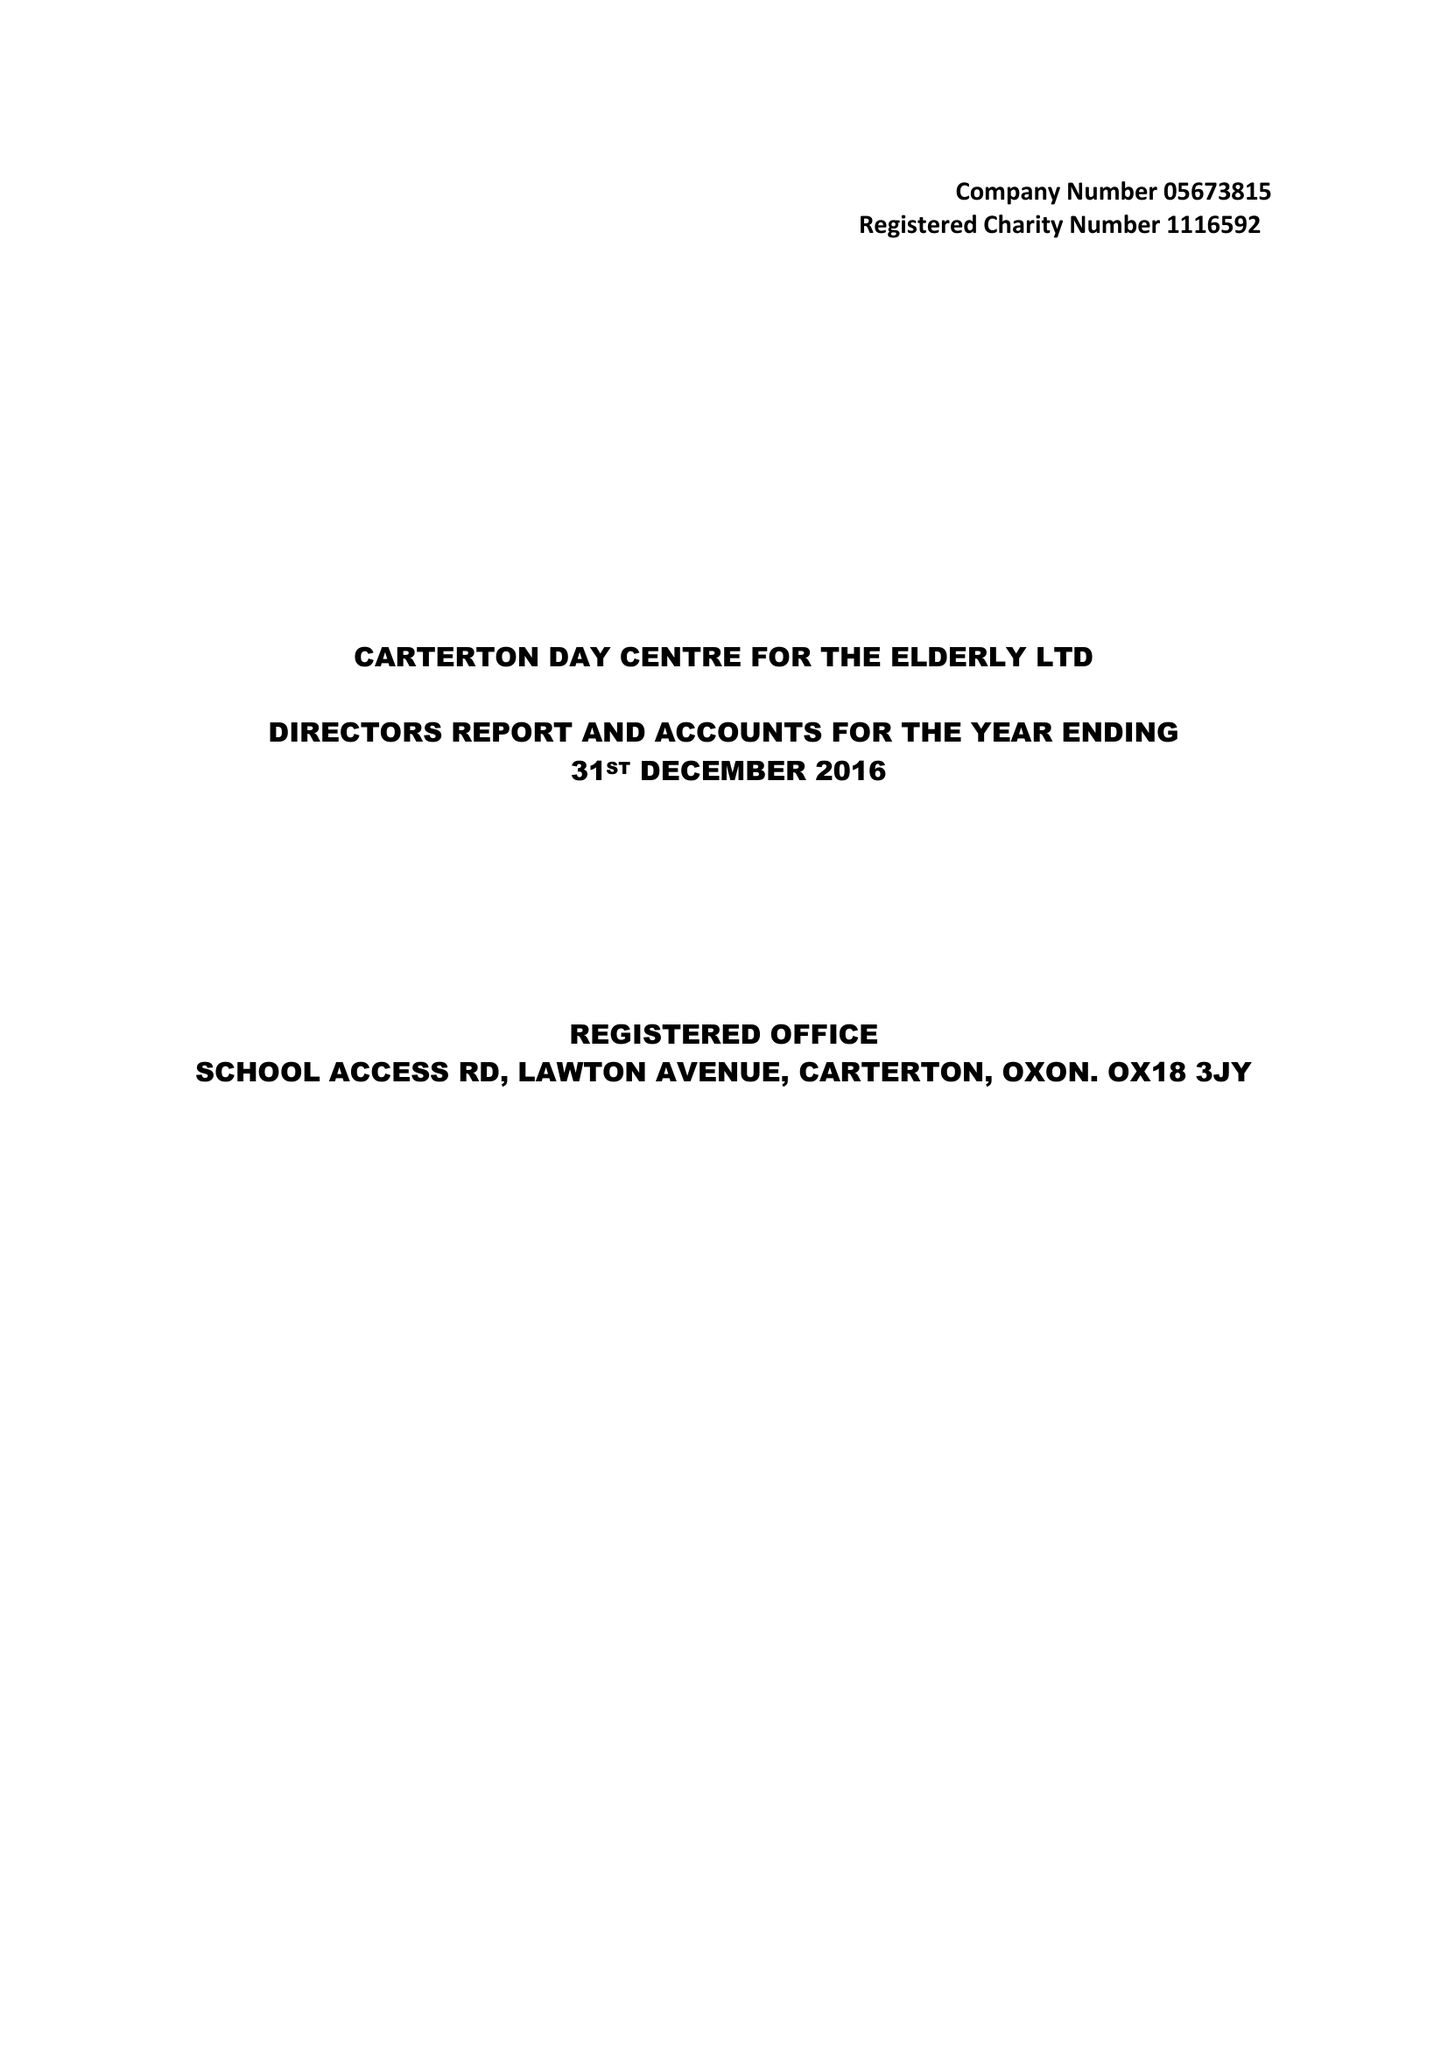What is the value for the report_date?
Answer the question using a single word or phrase. 2016-12-31 